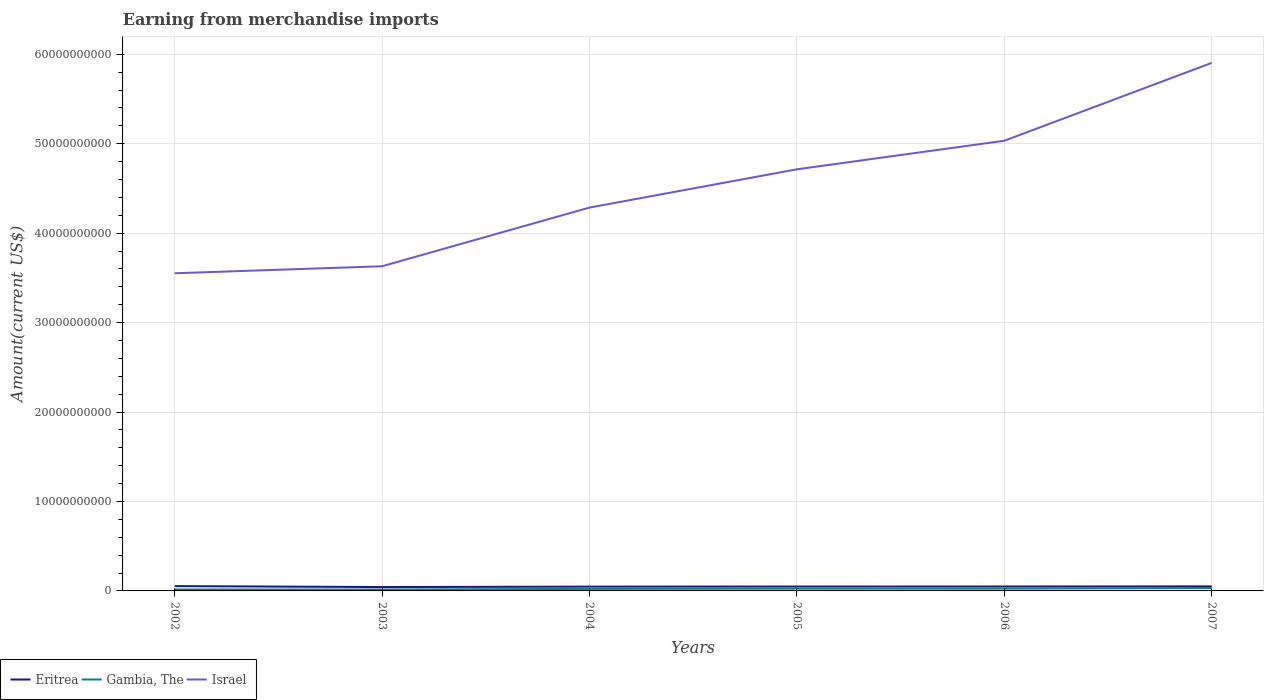Does the line corresponding to Gambia, The intersect with the line corresponding to Israel?
Give a very brief answer. No. Is the number of lines equal to the number of legend labels?
Offer a terse response. Yes. Across all years, what is the maximum amount earned from merchandise imports in Eritrea?
Your answer should be very brief. 4.33e+08. What is the total amount earned from merchandise imports in Israel in the graph?
Your response must be concise. -7.47e+09. What is the difference between the highest and the second highest amount earned from merchandise imports in Eritrea?
Your answer should be very brief. 1.05e+08. Is the amount earned from merchandise imports in Eritrea strictly greater than the amount earned from merchandise imports in Israel over the years?
Ensure brevity in your answer.  Yes. How many lines are there?
Offer a terse response. 3. How many years are there in the graph?
Offer a terse response. 6. What is the difference between two consecutive major ticks on the Y-axis?
Your answer should be compact. 1.00e+1. Does the graph contain grids?
Offer a very short reply. Yes. What is the title of the graph?
Give a very brief answer. Earning from merchandise imports. What is the label or title of the X-axis?
Provide a succinct answer. Years. What is the label or title of the Y-axis?
Your response must be concise. Amount(current US$). What is the Amount(current US$) of Eritrea in 2002?
Make the answer very short. 5.38e+08. What is the Amount(current US$) in Gambia, The in 2002?
Your answer should be compact. 1.61e+08. What is the Amount(current US$) of Israel in 2002?
Keep it short and to the point. 3.55e+1. What is the Amount(current US$) of Eritrea in 2003?
Ensure brevity in your answer.  4.33e+08. What is the Amount(current US$) in Gambia, The in 2003?
Your answer should be compact. 1.56e+08. What is the Amount(current US$) in Israel in 2003?
Offer a terse response. 3.63e+1. What is the Amount(current US$) in Eritrea in 2004?
Ensure brevity in your answer.  4.80e+08. What is the Amount(current US$) in Gambia, The in 2004?
Provide a short and direct response. 2.29e+08. What is the Amount(current US$) of Israel in 2004?
Your answer should be very brief. 4.29e+1. What is the Amount(current US$) of Eritrea in 2005?
Provide a succinct answer. 4.90e+08. What is the Amount(current US$) in Gambia, The in 2005?
Ensure brevity in your answer.  2.60e+08. What is the Amount(current US$) of Israel in 2005?
Offer a terse response. 4.71e+1. What is the Amount(current US$) of Eritrea in 2006?
Ensure brevity in your answer.  4.95e+08. What is the Amount(current US$) of Gambia, The in 2006?
Keep it short and to the point. 2.59e+08. What is the Amount(current US$) in Israel in 2006?
Offer a very short reply. 5.03e+1. What is the Amount(current US$) in Eritrea in 2007?
Your response must be concise. 5.10e+08. What is the Amount(current US$) of Gambia, The in 2007?
Your answer should be very brief. 3.21e+08. What is the Amount(current US$) of Israel in 2007?
Keep it short and to the point. 5.90e+1. Across all years, what is the maximum Amount(current US$) in Eritrea?
Your answer should be compact. 5.38e+08. Across all years, what is the maximum Amount(current US$) in Gambia, The?
Provide a short and direct response. 3.21e+08. Across all years, what is the maximum Amount(current US$) in Israel?
Your answer should be very brief. 5.90e+1. Across all years, what is the minimum Amount(current US$) of Eritrea?
Keep it short and to the point. 4.33e+08. Across all years, what is the minimum Amount(current US$) of Gambia, The?
Provide a succinct answer. 1.56e+08. Across all years, what is the minimum Amount(current US$) in Israel?
Offer a terse response. 3.55e+1. What is the total Amount(current US$) in Eritrea in the graph?
Offer a terse response. 2.95e+09. What is the total Amount(current US$) in Gambia, The in the graph?
Provide a short and direct response. 1.39e+09. What is the total Amount(current US$) in Israel in the graph?
Your response must be concise. 2.71e+11. What is the difference between the Amount(current US$) in Eritrea in 2002 and that in 2003?
Ensure brevity in your answer.  1.05e+08. What is the difference between the Amount(current US$) of Gambia, The in 2002 and that in 2003?
Give a very brief answer. 4.14e+06. What is the difference between the Amount(current US$) in Israel in 2002 and that in 2003?
Your answer should be very brief. -7.86e+08. What is the difference between the Amount(current US$) in Eritrea in 2002 and that in 2004?
Your answer should be compact. 5.79e+07. What is the difference between the Amount(current US$) in Gambia, The in 2002 and that in 2004?
Make the answer very short. -6.83e+07. What is the difference between the Amount(current US$) in Israel in 2002 and that in 2004?
Your answer should be very brief. -7.35e+09. What is the difference between the Amount(current US$) in Eritrea in 2002 and that in 2005?
Your answer should be compact. 4.79e+07. What is the difference between the Amount(current US$) in Gambia, The in 2002 and that in 2005?
Provide a short and direct response. -9.90e+07. What is the difference between the Amount(current US$) of Israel in 2002 and that in 2005?
Offer a terse response. -1.16e+1. What is the difference between the Amount(current US$) of Eritrea in 2002 and that in 2006?
Make the answer very short. 4.29e+07. What is the difference between the Amount(current US$) in Gambia, The in 2002 and that in 2006?
Ensure brevity in your answer.  -9.87e+07. What is the difference between the Amount(current US$) of Israel in 2002 and that in 2006?
Make the answer very short. -1.48e+1. What is the difference between the Amount(current US$) in Eritrea in 2002 and that in 2007?
Your response must be concise. 2.79e+07. What is the difference between the Amount(current US$) in Gambia, The in 2002 and that in 2007?
Keep it short and to the point. -1.60e+08. What is the difference between the Amount(current US$) in Israel in 2002 and that in 2007?
Offer a terse response. -2.35e+1. What is the difference between the Amount(current US$) of Eritrea in 2003 and that in 2004?
Your response must be concise. -4.72e+07. What is the difference between the Amount(current US$) in Gambia, The in 2003 and that in 2004?
Your answer should be very brief. -7.24e+07. What is the difference between the Amount(current US$) of Israel in 2003 and that in 2004?
Your answer should be very brief. -6.56e+09. What is the difference between the Amount(current US$) in Eritrea in 2003 and that in 2005?
Your answer should be compact. -5.72e+07. What is the difference between the Amount(current US$) of Gambia, The in 2003 and that in 2005?
Your answer should be compact. -1.03e+08. What is the difference between the Amount(current US$) of Israel in 2003 and that in 2005?
Give a very brief answer. -1.08e+1. What is the difference between the Amount(current US$) of Eritrea in 2003 and that in 2006?
Your response must be concise. -6.22e+07. What is the difference between the Amount(current US$) of Gambia, The in 2003 and that in 2006?
Ensure brevity in your answer.  -1.03e+08. What is the difference between the Amount(current US$) of Israel in 2003 and that in 2006?
Offer a terse response. -1.40e+1. What is the difference between the Amount(current US$) of Eritrea in 2003 and that in 2007?
Offer a terse response. -7.72e+07. What is the difference between the Amount(current US$) of Gambia, The in 2003 and that in 2007?
Your response must be concise. -1.64e+08. What is the difference between the Amount(current US$) in Israel in 2003 and that in 2007?
Provide a succinct answer. -2.27e+1. What is the difference between the Amount(current US$) of Eritrea in 2004 and that in 2005?
Your response must be concise. -1.00e+07. What is the difference between the Amount(current US$) in Gambia, The in 2004 and that in 2005?
Offer a very short reply. -3.07e+07. What is the difference between the Amount(current US$) of Israel in 2004 and that in 2005?
Make the answer very short. -4.28e+09. What is the difference between the Amount(current US$) of Eritrea in 2004 and that in 2006?
Give a very brief answer. -1.50e+07. What is the difference between the Amount(current US$) of Gambia, The in 2004 and that in 2006?
Keep it short and to the point. -3.04e+07. What is the difference between the Amount(current US$) in Israel in 2004 and that in 2006?
Give a very brief answer. -7.47e+09. What is the difference between the Amount(current US$) in Eritrea in 2004 and that in 2007?
Offer a very short reply. -3.00e+07. What is the difference between the Amount(current US$) in Gambia, The in 2004 and that in 2007?
Offer a terse response. -9.21e+07. What is the difference between the Amount(current US$) in Israel in 2004 and that in 2007?
Ensure brevity in your answer.  -1.62e+1. What is the difference between the Amount(current US$) of Eritrea in 2005 and that in 2006?
Provide a short and direct response. -5.00e+06. What is the difference between the Amount(current US$) of Gambia, The in 2005 and that in 2006?
Provide a short and direct response. 2.91e+05. What is the difference between the Amount(current US$) of Israel in 2005 and that in 2006?
Make the answer very short. -3.19e+09. What is the difference between the Amount(current US$) in Eritrea in 2005 and that in 2007?
Provide a succinct answer. -2.00e+07. What is the difference between the Amount(current US$) of Gambia, The in 2005 and that in 2007?
Ensure brevity in your answer.  -6.14e+07. What is the difference between the Amount(current US$) in Israel in 2005 and that in 2007?
Make the answer very short. -1.19e+1. What is the difference between the Amount(current US$) in Eritrea in 2006 and that in 2007?
Keep it short and to the point. -1.50e+07. What is the difference between the Amount(current US$) of Gambia, The in 2006 and that in 2007?
Offer a terse response. -6.17e+07. What is the difference between the Amount(current US$) in Israel in 2006 and that in 2007?
Your answer should be very brief. -8.70e+09. What is the difference between the Amount(current US$) of Eritrea in 2002 and the Amount(current US$) of Gambia, The in 2003?
Offer a terse response. 3.81e+08. What is the difference between the Amount(current US$) in Eritrea in 2002 and the Amount(current US$) in Israel in 2003?
Make the answer very short. -3.58e+1. What is the difference between the Amount(current US$) in Gambia, The in 2002 and the Amount(current US$) in Israel in 2003?
Keep it short and to the point. -3.61e+1. What is the difference between the Amount(current US$) of Eritrea in 2002 and the Amount(current US$) of Gambia, The in 2004?
Your answer should be compact. 3.09e+08. What is the difference between the Amount(current US$) in Eritrea in 2002 and the Amount(current US$) in Israel in 2004?
Give a very brief answer. -4.23e+1. What is the difference between the Amount(current US$) in Gambia, The in 2002 and the Amount(current US$) in Israel in 2004?
Offer a very short reply. -4.27e+1. What is the difference between the Amount(current US$) of Eritrea in 2002 and the Amount(current US$) of Gambia, The in 2005?
Offer a terse response. 2.78e+08. What is the difference between the Amount(current US$) of Eritrea in 2002 and the Amount(current US$) of Israel in 2005?
Your answer should be compact. -4.66e+1. What is the difference between the Amount(current US$) in Gambia, The in 2002 and the Amount(current US$) in Israel in 2005?
Keep it short and to the point. -4.70e+1. What is the difference between the Amount(current US$) in Eritrea in 2002 and the Amount(current US$) in Gambia, The in 2006?
Keep it short and to the point. 2.79e+08. What is the difference between the Amount(current US$) in Eritrea in 2002 and the Amount(current US$) in Israel in 2006?
Your response must be concise. -4.98e+1. What is the difference between the Amount(current US$) in Gambia, The in 2002 and the Amount(current US$) in Israel in 2006?
Your response must be concise. -5.02e+1. What is the difference between the Amount(current US$) in Eritrea in 2002 and the Amount(current US$) in Gambia, The in 2007?
Provide a short and direct response. 2.17e+08. What is the difference between the Amount(current US$) in Eritrea in 2002 and the Amount(current US$) in Israel in 2007?
Keep it short and to the point. -5.85e+1. What is the difference between the Amount(current US$) in Gambia, The in 2002 and the Amount(current US$) in Israel in 2007?
Offer a terse response. -5.89e+1. What is the difference between the Amount(current US$) in Eritrea in 2003 and the Amount(current US$) in Gambia, The in 2004?
Offer a terse response. 2.04e+08. What is the difference between the Amount(current US$) in Eritrea in 2003 and the Amount(current US$) in Israel in 2004?
Your response must be concise. -4.24e+1. What is the difference between the Amount(current US$) of Gambia, The in 2003 and the Amount(current US$) of Israel in 2004?
Offer a terse response. -4.27e+1. What is the difference between the Amount(current US$) in Eritrea in 2003 and the Amount(current US$) in Gambia, The in 2005?
Make the answer very short. 1.73e+08. What is the difference between the Amount(current US$) of Eritrea in 2003 and the Amount(current US$) of Israel in 2005?
Keep it short and to the point. -4.67e+1. What is the difference between the Amount(current US$) in Gambia, The in 2003 and the Amount(current US$) in Israel in 2005?
Offer a very short reply. -4.70e+1. What is the difference between the Amount(current US$) of Eritrea in 2003 and the Amount(current US$) of Gambia, The in 2006?
Provide a short and direct response. 1.74e+08. What is the difference between the Amount(current US$) of Eritrea in 2003 and the Amount(current US$) of Israel in 2006?
Offer a very short reply. -4.99e+1. What is the difference between the Amount(current US$) of Gambia, The in 2003 and the Amount(current US$) of Israel in 2006?
Your response must be concise. -5.02e+1. What is the difference between the Amount(current US$) in Eritrea in 2003 and the Amount(current US$) in Gambia, The in 2007?
Keep it short and to the point. 1.12e+08. What is the difference between the Amount(current US$) in Eritrea in 2003 and the Amount(current US$) in Israel in 2007?
Offer a terse response. -5.86e+1. What is the difference between the Amount(current US$) of Gambia, The in 2003 and the Amount(current US$) of Israel in 2007?
Provide a succinct answer. -5.89e+1. What is the difference between the Amount(current US$) in Eritrea in 2004 and the Amount(current US$) in Gambia, The in 2005?
Keep it short and to the point. 2.20e+08. What is the difference between the Amount(current US$) in Eritrea in 2004 and the Amount(current US$) in Israel in 2005?
Your answer should be compact. -4.67e+1. What is the difference between the Amount(current US$) in Gambia, The in 2004 and the Amount(current US$) in Israel in 2005?
Keep it short and to the point. -4.69e+1. What is the difference between the Amount(current US$) in Eritrea in 2004 and the Amount(current US$) in Gambia, The in 2006?
Your answer should be compact. 2.21e+08. What is the difference between the Amount(current US$) of Eritrea in 2004 and the Amount(current US$) of Israel in 2006?
Offer a very short reply. -4.99e+1. What is the difference between the Amount(current US$) in Gambia, The in 2004 and the Amount(current US$) in Israel in 2006?
Your answer should be compact. -5.01e+1. What is the difference between the Amount(current US$) of Eritrea in 2004 and the Amount(current US$) of Gambia, The in 2007?
Provide a succinct answer. 1.59e+08. What is the difference between the Amount(current US$) in Eritrea in 2004 and the Amount(current US$) in Israel in 2007?
Offer a terse response. -5.86e+1. What is the difference between the Amount(current US$) in Gambia, The in 2004 and the Amount(current US$) in Israel in 2007?
Your response must be concise. -5.88e+1. What is the difference between the Amount(current US$) of Eritrea in 2005 and the Amount(current US$) of Gambia, The in 2006?
Ensure brevity in your answer.  2.31e+08. What is the difference between the Amount(current US$) of Eritrea in 2005 and the Amount(current US$) of Israel in 2006?
Provide a succinct answer. -4.98e+1. What is the difference between the Amount(current US$) of Gambia, The in 2005 and the Amount(current US$) of Israel in 2006?
Give a very brief answer. -5.01e+1. What is the difference between the Amount(current US$) of Eritrea in 2005 and the Amount(current US$) of Gambia, The in 2007?
Offer a very short reply. 1.69e+08. What is the difference between the Amount(current US$) in Eritrea in 2005 and the Amount(current US$) in Israel in 2007?
Provide a succinct answer. -5.85e+1. What is the difference between the Amount(current US$) of Gambia, The in 2005 and the Amount(current US$) of Israel in 2007?
Keep it short and to the point. -5.88e+1. What is the difference between the Amount(current US$) in Eritrea in 2006 and the Amount(current US$) in Gambia, The in 2007?
Your answer should be very brief. 1.74e+08. What is the difference between the Amount(current US$) in Eritrea in 2006 and the Amount(current US$) in Israel in 2007?
Make the answer very short. -5.85e+1. What is the difference between the Amount(current US$) of Gambia, The in 2006 and the Amount(current US$) of Israel in 2007?
Ensure brevity in your answer.  -5.88e+1. What is the average Amount(current US$) of Eritrea per year?
Give a very brief answer. 4.91e+08. What is the average Amount(current US$) of Gambia, The per year?
Make the answer very short. 2.31e+08. What is the average Amount(current US$) in Israel per year?
Provide a succinct answer. 4.52e+1. In the year 2002, what is the difference between the Amount(current US$) of Eritrea and Amount(current US$) of Gambia, The?
Ensure brevity in your answer.  3.77e+08. In the year 2002, what is the difference between the Amount(current US$) of Eritrea and Amount(current US$) of Israel?
Your response must be concise. -3.50e+1. In the year 2002, what is the difference between the Amount(current US$) in Gambia, The and Amount(current US$) in Israel?
Your response must be concise. -3.54e+1. In the year 2003, what is the difference between the Amount(current US$) of Eritrea and Amount(current US$) of Gambia, The?
Provide a succinct answer. 2.76e+08. In the year 2003, what is the difference between the Amount(current US$) of Eritrea and Amount(current US$) of Israel?
Ensure brevity in your answer.  -3.59e+1. In the year 2003, what is the difference between the Amount(current US$) in Gambia, The and Amount(current US$) in Israel?
Provide a succinct answer. -3.61e+1. In the year 2004, what is the difference between the Amount(current US$) in Eritrea and Amount(current US$) in Gambia, The?
Keep it short and to the point. 2.51e+08. In the year 2004, what is the difference between the Amount(current US$) of Eritrea and Amount(current US$) of Israel?
Your answer should be very brief. -4.24e+1. In the year 2004, what is the difference between the Amount(current US$) of Gambia, The and Amount(current US$) of Israel?
Provide a short and direct response. -4.26e+1. In the year 2005, what is the difference between the Amount(current US$) of Eritrea and Amount(current US$) of Gambia, The?
Your response must be concise. 2.30e+08. In the year 2005, what is the difference between the Amount(current US$) of Eritrea and Amount(current US$) of Israel?
Your answer should be compact. -4.67e+1. In the year 2005, what is the difference between the Amount(current US$) of Gambia, The and Amount(current US$) of Israel?
Ensure brevity in your answer.  -4.69e+1. In the year 2006, what is the difference between the Amount(current US$) of Eritrea and Amount(current US$) of Gambia, The?
Make the answer very short. 2.36e+08. In the year 2006, what is the difference between the Amount(current US$) in Eritrea and Amount(current US$) in Israel?
Provide a short and direct response. -4.98e+1. In the year 2006, what is the difference between the Amount(current US$) in Gambia, The and Amount(current US$) in Israel?
Offer a terse response. -5.01e+1. In the year 2007, what is the difference between the Amount(current US$) in Eritrea and Amount(current US$) in Gambia, The?
Offer a very short reply. 1.89e+08. In the year 2007, what is the difference between the Amount(current US$) in Eritrea and Amount(current US$) in Israel?
Provide a succinct answer. -5.85e+1. In the year 2007, what is the difference between the Amount(current US$) of Gambia, The and Amount(current US$) of Israel?
Give a very brief answer. -5.87e+1. What is the ratio of the Amount(current US$) in Eritrea in 2002 to that in 2003?
Provide a succinct answer. 1.24. What is the ratio of the Amount(current US$) in Gambia, The in 2002 to that in 2003?
Ensure brevity in your answer.  1.03. What is the ratio of the Amount(current US$) of Israel in 2002 to that in 2003?
Keep it short and to the point. 0.98. What is the ratio of the Amount(current US$) of Eritrea in 2002 to that in 2004?
Make the answer very short. 1.12. What is the ratio of the Amount(current US$) in Gambia, The in 2002 to that in 2004?
Give a very brief answer. 0.7. What is the ratio of the Amount(current US$) in Israel in 2002 to that in 2004?
Offer a very short reply. 0.83. What is the ratio of the Amount(current US$) of Eritrea in 2002 to that in 2005?
Your answer should be compact. 1.1. What is the ratio of the Amount(current US$) of Gambia, The in 2002 to that in 2005?
Offer a terse response. 0.62. What is the ratio of the Amount(current US$) in Israel in 2002 to that in 2005?
Offer a very short reply. 0.75. What is the ratio of the Amount(current US$) in Eritrea in 2002 to that in 2006?
Keep it short and to the point. 1.09. What is the ratio of the Amount(current US$) in Gambia, The in 2002 to that in 2006?
Provide a succinct answer. 0.62. What is the ratio of the Amount(current US$) in Israel in 2002 to that in 2006?
Give a very brief answer. 0.71. What is the ratio of the Amount(current US$) of Eritrea in 2002 to that in 2007?
Keep it short and to the point. 1.05. What is the ratio of the Amount(current US$) in Gambia, The in 2002 to that in 2007?
Ensure brevity in your answer.  0.5. What is the ratio of the Amount(current US$) in Israel in 2002 to that in 2007?
Provide a succinct answer. 0.6. What is the ratio of the Amount(current US$) of Eritrea in 2003 to that in 2004?
Your answer should be very brief. 0.9. What is the ratio of the Amount(current US$) of Gambia, The in 2003 to that in 2004?
Your answer should be compact. 0.68. What is the ratio of the Amount(current US$) of Israel in 2003 to that in 2004?
Your answer should be compact. 0.85. What is the ratio of the Amount(current US$) in Eritrea in 2003 to that in 2005?
Provide a succinct answer. 0.88. What is the ratio of the Amount(current US$) in Gambia, The in 2003 to that in 2005?
Keep it short and to the point. 0.6. What is the ratio of the Amount(current US$) of Israel in 2003 to that in 2005?
Ensure brevity in your answer.  0.77. What is the ratio of the Amount(current US$) in Eritrea in 2003 to that in 2006?
Your answer should be compact. 0.87. What is the ratio of the Amount(current US$) of Gambia, The in 2003 to that in 2006?
Ensure brevity in your answer.  0.6. What is the ratio of the Amount(current US$) in Israel in 2003 to that in 2006?
Your answer should be very brief. 0.72. What is the ratio of the Amount(current US$) of Eritrea in 2003 to that in 2007?
Keep it short and to the point. 0.85. What is the ratio of the Amount(current US$) in Gambia, The in 2003 to that in 2007?
Your answer should be compact. 0.49. What is the ratio of the Amount(current US$) in Israel in 2003 to that in 2007?
Your response must be concise. 0.61. What is the ratio of the Amount(current US$) in Eritrea in 2004 to that in 2005?
Your answer should be compact. 0.98. What is the ratio of the Amount(current US$) of Gambia, The in 2004 to that in 2005?
Your answer should be compact. 0.88. What is the ratio of the Amount(current US$) of Israel in 2004 to that in 2005?
Provide a succinct answer. 0.91. What is the ratio of the Amount(current US$) of Eritrea in 2004 to that in 2006?
Make the answer very short. 0.97. What is the ratio of the Amount(current US$) of Gambia, The in 2004 to that in 2006?
Make the answer very short. 0.88. What is the ratio of the Amount(current US$) of Israel in 2004 to that in 2006?
Provide a succinct answer. 0.85. What is the ratio of the Amount(current US$) of Eritrea in 2004 to that in 2007?
Your answer should be compact. 0.94. What is the ratio of the Amount(current US$) in Gambia, The in 2004 to that in 2007?
Your answer should be very brief. 0.71. What is the ratio of the Amount(current US$) in Israel in 2004 to that in 2007?
Provide a short and direct response. 0.73. What is the ratio of the Amount(current US$) of Gambia, The in 2005 to that in 2006?
Give a very brief answer. 1. What is the ratio of the Amount(current US$) in Israel in 2005 to that in 2006?
Provide a short and direct response. 0.94. What is the ratio of the Amount(current US$) in Eritrea in 2005 to that in 2007?
Your answer should be very brief. 0.96. What is the ratio of the Amount(current US$) in Gambia, The in 2005 to that in 2007?
Ensure brevity in your answer.  0.81. What is the ratio of the Amount(current US$) in Israel in 2005 to that in 2007?
Give a very brief answer. 0.8. What is the ratio of the Amount(current US$) in Eritrea in 2006 to that in 2007?
Your answer should be compact. 0.97. What is the ratio of the Amount(current US$) of Gambia, The in 2006 to that in 2007?
Offer a very short reply. 0.81. What is the ratio of the Amount(current US$) in Israel in 2006 to that in 2007?
Provide a short and direct response. 0.85. What is the difference between the highest and the second highest Amount(current US$) of Eritrea?
Your answer should be very brief. 2.79e+07. What is the difference between the highest and the second highest Amount(current US$) in Gambia, The?
Provide a succinct answer. 6.14e+07. What is the difference between the highest and the second highest Amount(current US$) of Israel?
Provide a succinct answer. 8.70e+09. What is the difference between the highest and the lowest Amount(current US$) in Eritrea?
Your response must be concise. 1.05e+08. What is the difference between the highest and the lowest Amount(current US$) in Gambia, The?
Offer a terse response. 1.64e+08. What is the difference between the highest and the lowest Amount(current US$) of Israel?
Offer a very short reply. 2.35e+1. 